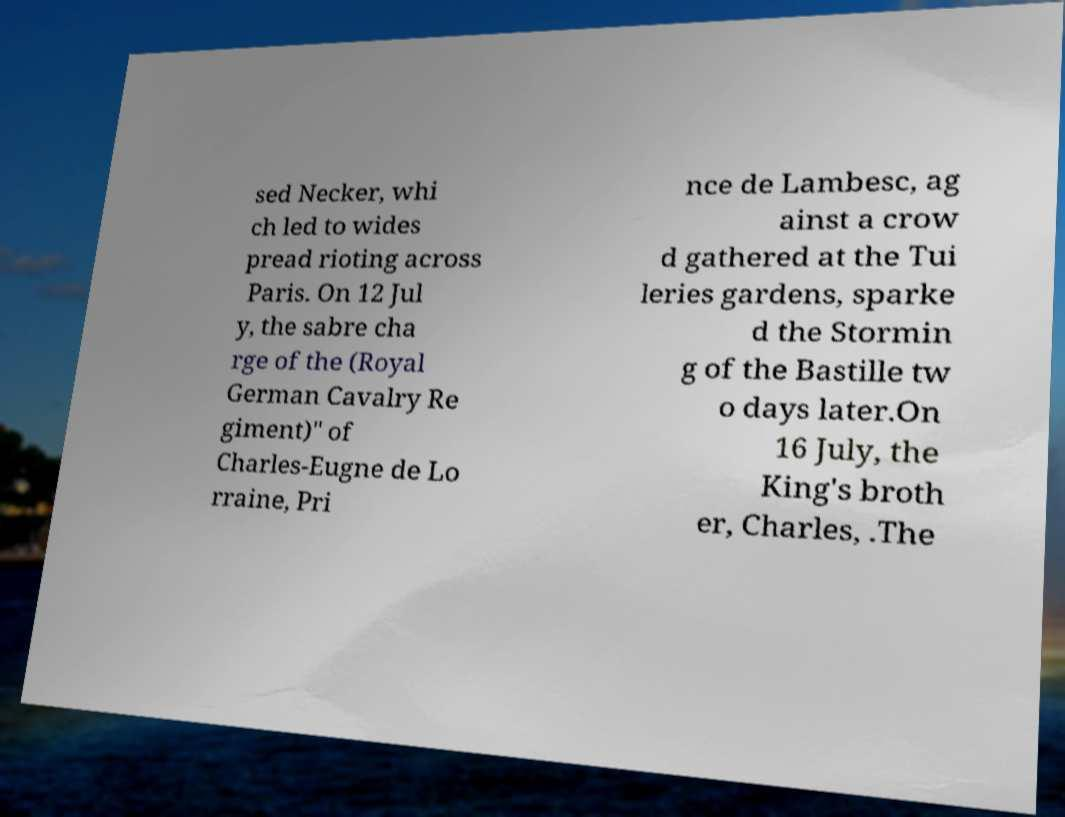Could you assist in decoding the text presented in this image and type it out clearly? sed Necker, whi ch led to wides pread rioting across Paris. On 12 Jul y, the sabre cha rge of the (Royal German Cavalry Re giment)" of Charles-Eugne de Lo rraine, Pri nce de Lambesc, ag ainst a crow d gathered at the Tui leries gardens, sparke d the Stormin g of the Bastille tw o days later.On 16 July, the King's broth er, Charles, .The 